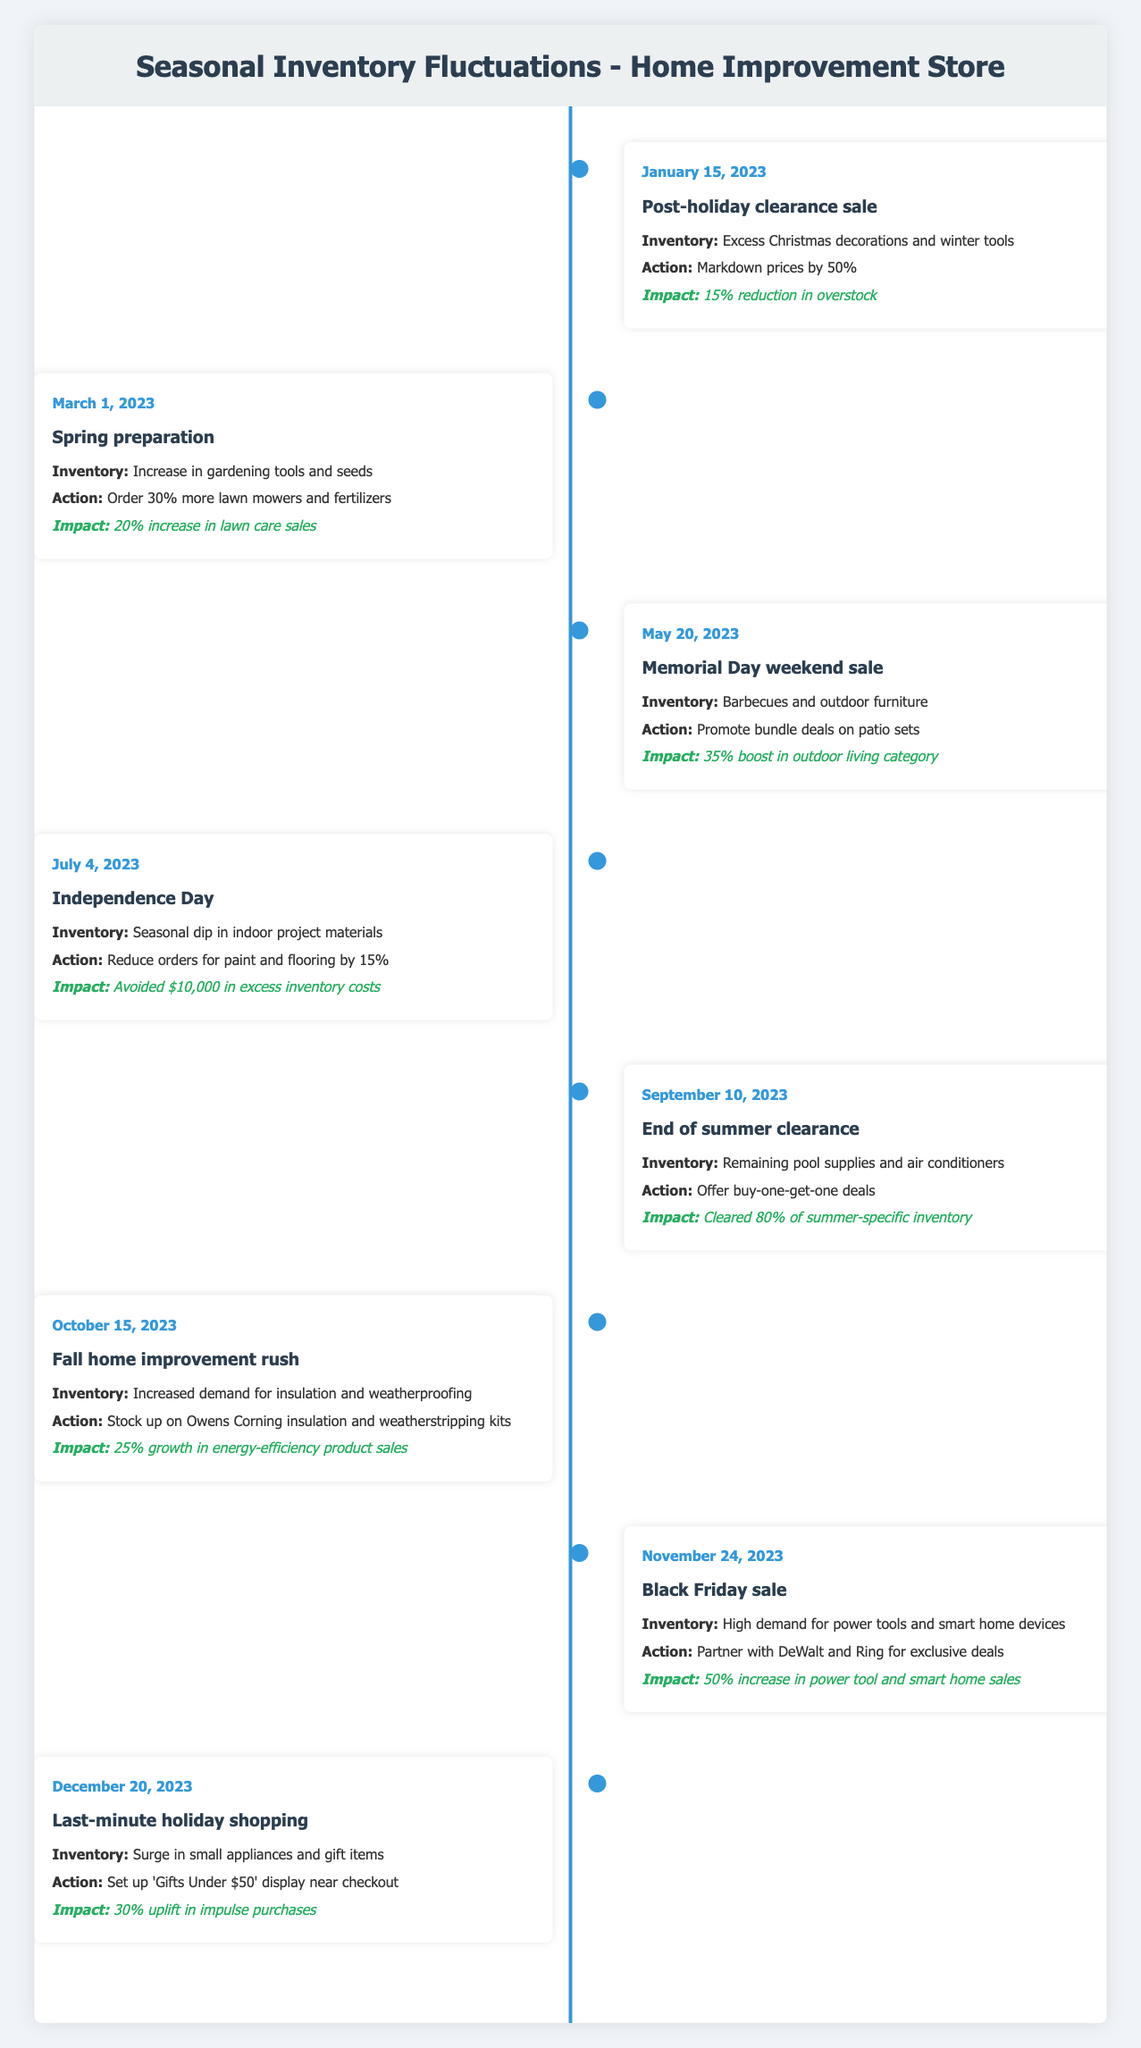What event occurred on January 15, 2023? The table indicates that on January 15, 2023, the event was a post-holiday clearance sale. This can be found in the "event" column for that date.
Answer: Post-holiday clearance sale What impact did the Memorial Day weekend sale have on outdoor living category sales? From the table, the Memorial Day weekend sale resulted in a 35% boost in outdoor living category sales, which is stated in the "impact" column for that event.
Answer: 35% boost in outdoor living category Did inventory reduce for paint and flooring during Independence Day? The table presents that the action taken on Independence Day was to reduce orders for paint and flooring by 15%, which implies a reduction in inventory. Thus, the answer is yes.
Answer: Yes What was the date of the Black Friday sale? The Black Friday sale occurred on November 24, 2023, which is clearly indicated in the "date" column for that event.
Answer: November 24, 2023 What was the percentage increase in energy-efficiency product sales during the fall home improvement rush compared to the previous inventory period? The table states that there was a 25% growth in energy-efficiency product sales during the fall home improvement rush. To determine the comparison to the previous inventory period would require considering prior sales, which is not provided here. Therefore, we just report the increase figure.
Answer: 25% How many events focused on reducing excess inventory from seasonal sales? Reviewing the table reveals 4 events that focused on reducing excess inventory: the post-holiday clearance sale, the end of summer clearance, and the actions related to Independence Day and Black Friday.
Answer: 4 What actions were taken on March 1, 2023, and what was the impact? The actions taken on March 1, 2023, included ordering 30% more lawn mowers and fertilizers, leading to a 20% increase in lawn care sales. This can be confirmed by reviewing both the "action" and "impact" columns for that date.
Answer: Order 30% more lawn mowers and fertilizers; 20% increase in lawn care sales What type of inventory surged before the last-minute holiday shopping event? The table notes that there was a surge in small appliances and gift items before the last-minute holiday shopping event on December 20, 2023, as indicated in the "inventory" column.
Answer: Small appliances and gift items What reduction in overstock was achieved from the post-holiday clearance sale? According to the table, the post-holiday clearance sale led to a 15% reduction in overstock, as shown in the "impact" column for January 15, 2023.
Answer: 15% reduction in overstock 